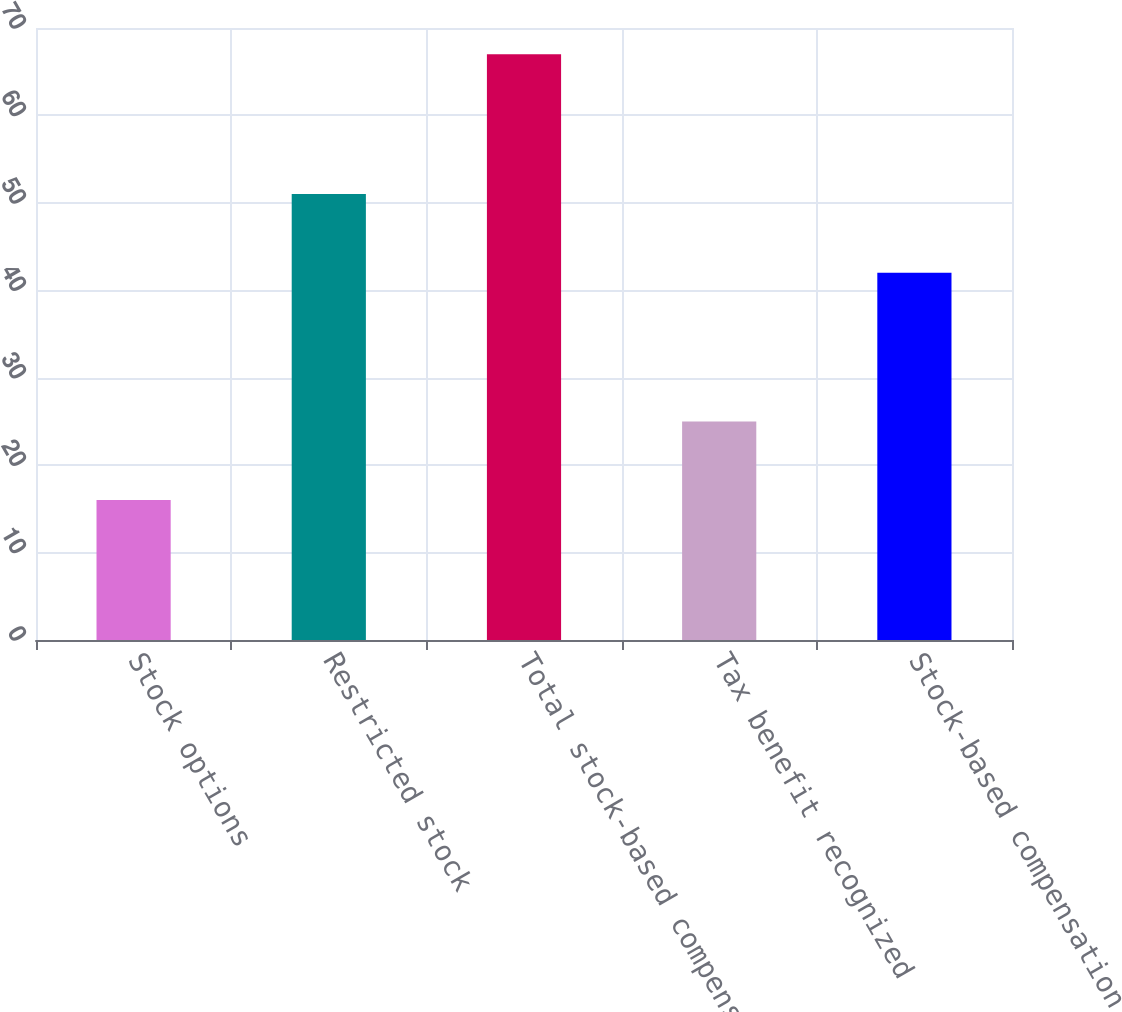<chart> <loc_0><loc_0><loc_500><loc_500><bar_chart><fcel>Stock options<fcel>Restricted stock<fcel>Total stock-based compensation<fcel>Tax benefit recognized<fcel>Stock-based compensation<nl><fcel>16<fcel>51<fcel>67<fcel>25<fcel>42<nl></chart> 